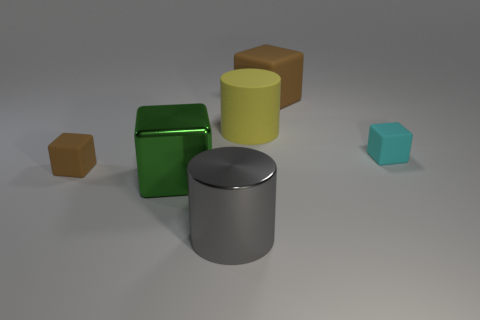How many big rubber blocks are behind the brown thing on the right side of the shiny cylinder?
Your response must be concise. 0. What number of other things have the same shape as the gray metal thing?
Your answer should be very brief. 1. How many metallic cylinders are there?
Provide a succinct answer. 1. What is the color of the matte thing on the left side of the gray cylinder?
Your answer should be very brief. Brown. What is the color of the large rubber thing left of the matte cube behind the large yellow object?
Your answer should be compact. Yellow. There is a rubber cube that is the same size as the cyan matte thing; what color is it?
Your response must be concise. Brown. What number of things are both behind the large shiny block and on the left side of the gray object?
Offer a very short reply. 1. The matte object that is the same color as the large rubber cube is what shape?
Offer a very short reply. Cube. There is a block that is behind the big green block and in front of the tiny cyan matte thing; what material is it?
Ensure brevity in your answer.  Rubber. Is the number of green blocks behind the large matte block less than the number of large cylinders that are behind the green metallic thing?
Offer a very short reply. Yes. 